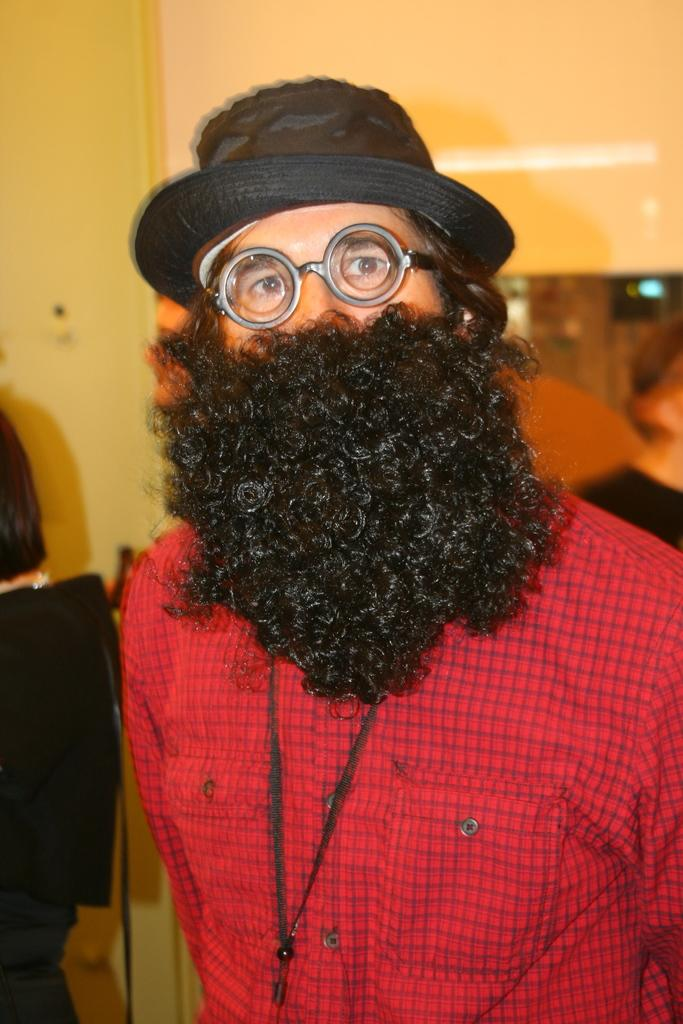Who is present in the image? There is a man in the image. What is the man wearing on his upper body? The man is wearing a red shirt. What type of headwear is the man wearing? The man is wearing a cap. What accessory is the man wearing on his face? The man is wearing glasses. What type of facial hair is the man wearing? The man has a beard wig. What can be seen in the background of the image? There are other people and a wall in the background of the image. What type of sheet is draped over the deer in the image? There is no deer present in the image, and therefore no sheet can be draped over it. 